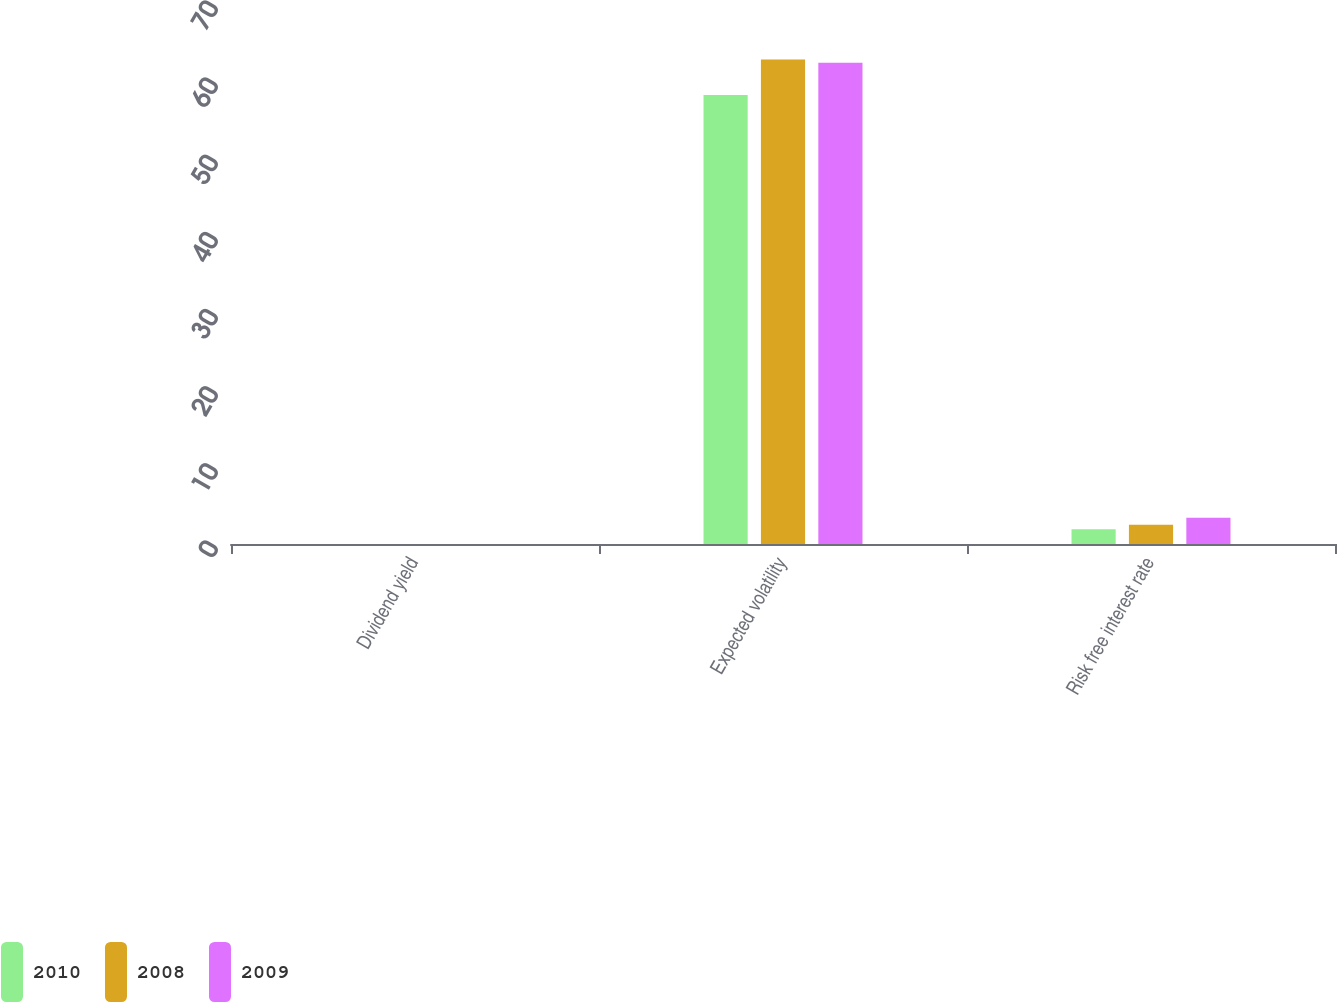Convert chart to OTSL. <chart><loc_0><loc_0><loc_500><loc_500><stacked_bar_chart><ecel><fcel>Dividend yield<fcel>Expected volatility<fcel>Risk free interest rate<nl><fcel>2010<fcel>0<fcel>58.2<fcel>1.9<nl><fcel>2008<fcel>0<fcel>62.8<fcel>2.5<nl><fcel>2009<fcel>0<fcel>62.4<fcel>3.4<nl></chart> 